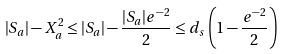<formula> <loc_0><loc_0><loc_500><loc_500>| S _ { a } | - X _ { a } ^ { 2 } \leq | S _ { a } | - \frac { | S _ { a } | e ^ { - 2 } } { 2 } \leq d _ { s } \left ( 1 - \frac { e ^ { - 2 } } { 2 } \right )</formula> 